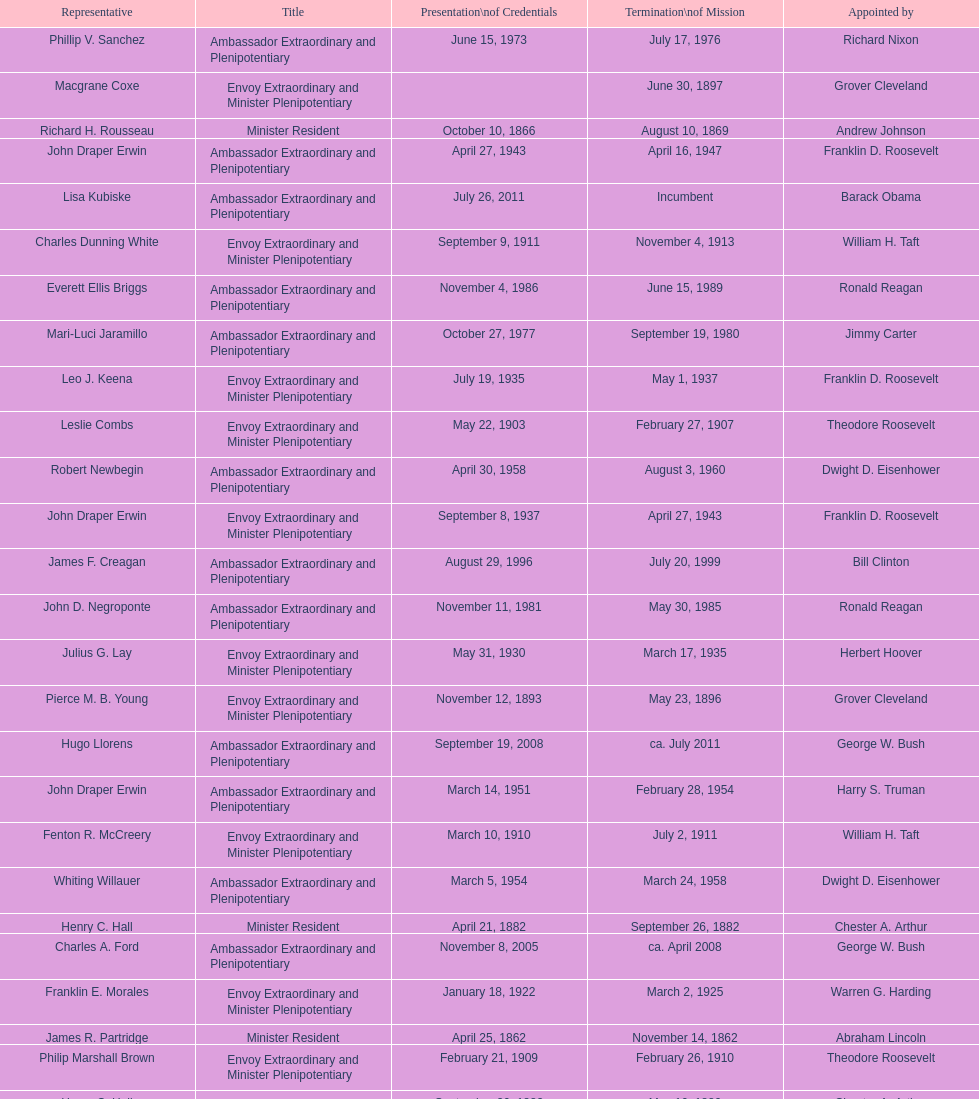Who became the ambassador after the completion of hewson ryan's mission? Phillip V. Sanchez. 